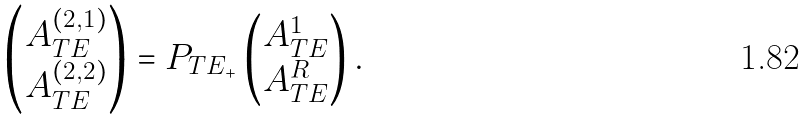<formula> <loc_0><loc_0><loc_500><loc_500>\begin{pmatrix} A ^ { ( 2 , 1 ) } _ { T E } \\ A ^ { ( 2 , 2 ) } _ { T E } \end{pmatrix} = P _ { T E _ { + } } \begin{pmatrix} A ^ { 1 } _ { T E } \\ A ^ { R } _ { T E } \end{pmatrix} .</formula> 